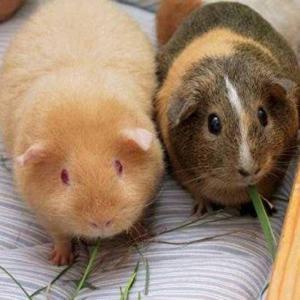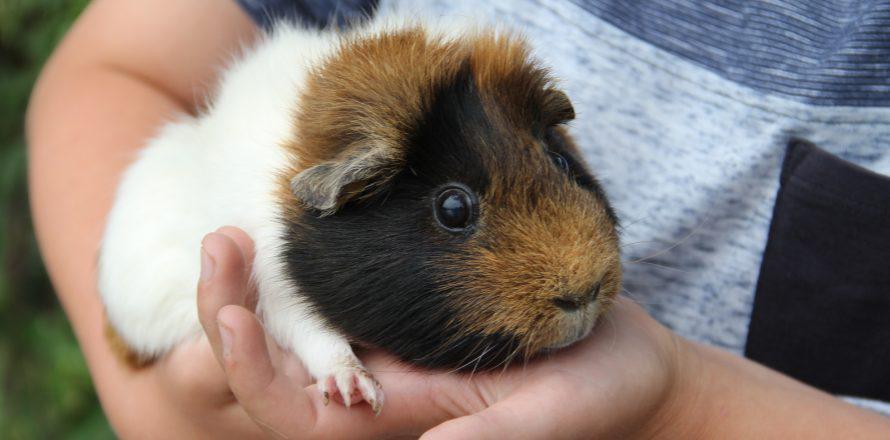The first image is the image on the left, the second image is the image on the right. Analyze the images presented: Is the assertion "One image shows a single multicolor pet rodent held in a human hand." valid? Answer yes or no. Yes. The first image is the image on the left, the second image is the image on the right. Considering the images on both sides, is "The right image contains exactly two guinea pigs." valid? Answer yes or no. No. 